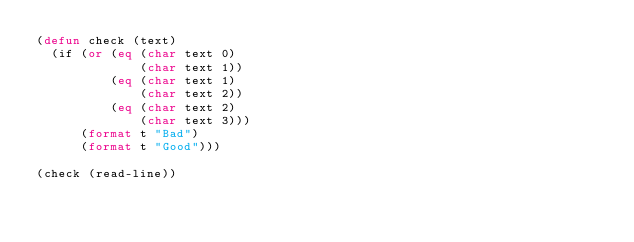Convert code to text. <code><loc_0><loc_0><loc_500><loc_500><_Lisp_>(defun check (text)
  (if (or (eq (char text 0)
              (char text 1))
          (eq (char text 1)
              (char text 2))
          (eq (char text 2)
              (char text 3)))
      (format t "Bad")
      (format t "Good")))

(check (read-line))</code> 